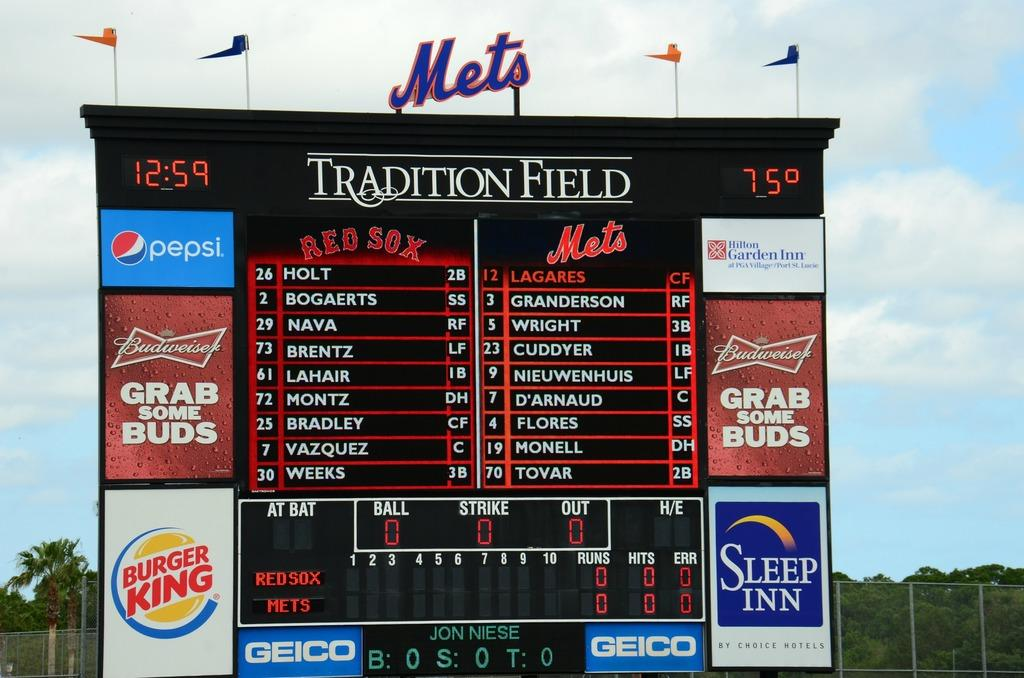<image>
Describe the image concisely. The score board at tradition field shows the line up between the Mets and Red Sox. 